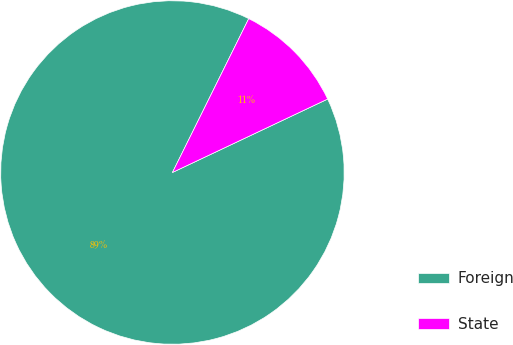Convert chart to OTSL. <chart><loc_0><loc_0><loc_500><loc_500><pie_chart><fcel>Foreign<fcel>State<nl><fcel>89.36%<fcel>10.64%<nl></chart> 